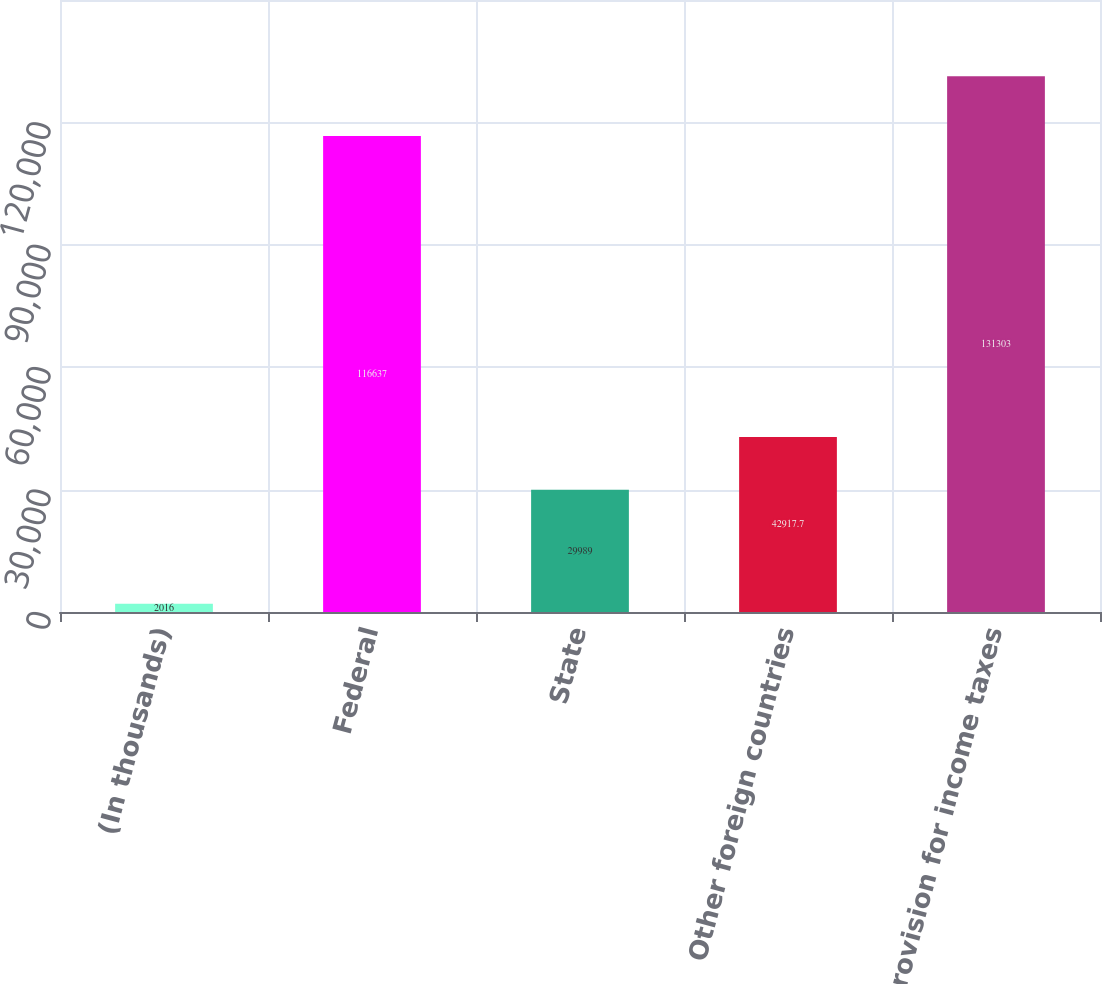<chart> <loc_0><loc_0><loc_500><loc_500><bar_chart><fcel>(In thousands)<fcel>Federal<fcel>State<fcel>Other foreign countries<fcel>Provision for income taxes<nl><fcel>2016<fcel>116637<fcel>29989<fcel>42917.7<fcel>131303<nl></chart> 